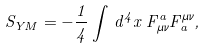<formula> <loc_0><loc_0><loc_500><loc_500>S _ { Y M } = - \frac { 1 } { 4 } \int \, d ^ { 4 } x \, F _ { \mu \nu } ^ { a } F ^ { \mu \nu } _ { a } ,</formula> 